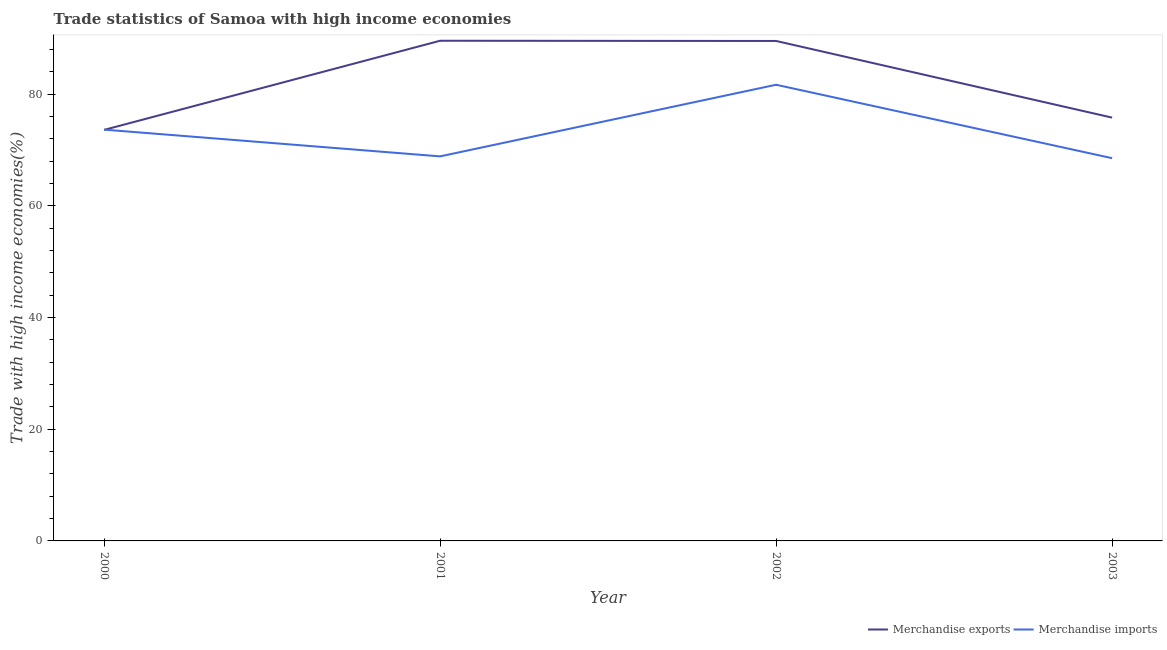How many different coloured lines are there?
Offer a very short reply. 2. Does the line corresponding to merchandise imports intersect with the line corresponding to merchandise exports?
Provide a short and direct response. Yes. Is the number of lines equal to the number of legend labels?
Keep it short and to the point. Yes. What is the merchandise exports in 2000?
Your response must be concise. 73.62. Across all years, what is the maximum merchandise imports?
Provide a succinct answer. 81.71. Across all years, what is the minimum merchandise exports?
Make the answer very short. 73.62. In which year was the merchandise exports maximum?
Offer a terse response. 2001. What is the total merchandise imports in the graph?
Ensure brevity in your answer.  292.82. What is the difference between the merchandise imports in 2000 and that in 2001?
Make the answer very short. 4.79. What is the difference between the merchandise exports in 2002 and the merchandise imports in 2001?
Your response must be concise. 20.67. What is the average merchandise imports per year?
Make the answer very short. 73.21. In the year 2002, what is the difference between the merchandise exports and merchandise imports?
Your answer should be very brief. 7.84. In how many years, is the merchandise imports greater than 12 %?
Offer a very short reply. 4. What is the ratio of the merchandise exports in 2002 to that in 2003?
Make the answer very short. 1.18. Is the merchandise imports in 2001 less than that in 2003?
Provide a succinct answer. No. Is the difference between the merchandise exports in 2000 and 2001 greater than the difference between the merchandise imports in 2000 and 2001?
Give a very brief answer. No. What is the difference between the highest and the second highest merchandise exports?
Make the answer very short. 0.04. What is the difference between the highest and the lowest merchandise exports?
Offer a very short reply. 15.97. Is the merchandise imports strictly less than the merchandise exports over the years?
Ensure brevity in your answer.  No. Are the values on the major ticks of Y-axis written in scientific E-notation?
Your answer should be very brief. No. What is the title of the graph?
Make the answer very short. Trade statistics of Samoa with high income economies. Does "Non-resident workers" appear as one of the legend labels in the graph?
Provide a short and direct response. No. What is the label or title of the Y-axis?
Give a very brief answer. Trade with high income economies(%). What is the Trade with high income economies(%) of Merchandise exports in 2000?
Your answer should be compact. 73.62. What is the Trade with high income economies(%) of Merchandise imports in 2000?
Offer a very short reply. 73.67. What is the Trade with high income economies(%) of Merchandise exports in 2001?
Keep it short and to the point. 89.59. What is the Trade with high income economies(%) of Merchandise imports in 2001?
Provide a short and direct response. 68.88. What is the Trade with high income economies(%) in Merchandise exports in 2002?
Your answer should be very brief. 89.55. What is the Trade with high income economies(%) of Merchandise imports in 2002?
Your answer should be compact. 81.71. What is the Trade with high income economies(%) of Merchandise exports in 2003?
Your answer should be very brief. 75.82. What is the Trade with high income economies(%) in Merchandise imports in 2003?
Make the answer very short. 68.56. Across all years, what is the maximum Trade with high income economies(%) of Merchandise exports?
Offer a terse response. 89.59. Across all years, what is the maximum Trade with high income economies(%) in Merchandise imports?
Ensure brevity in your answer.  81.71. Across all years, what is the minimum Trade with high income economies(%) in Merchandise exports?
Make the answer very short. 73.62. Across all years, what is the minimum Trade with high income economies(%) in Merchandise imports?
Ensure brevity in your answer.  68.56. What is the total Trade with high income economies(%) of Merchandise exports in the graph?
Give a very brief answer. 328.59. What is the total Trade with high income economies(%) of Merchandise imports in the graph?
Keep it short and to the point. 292.82. What is the difference between the Trade with high income economies(%) of Merchandise exports in 2000 and that in 2001?
Provide a succinct answer. -15.97. What is the difference between the Trade with high income economies(%) of Merchandise imports in 2000 and that in 2001?
Your answer should be very brief. 4.79. What is the difference between the Trade with high income economies(%) in Merchandise exports in 2000 and that in 2002?
Keep it short and to the point. -15.93. What is the difference between the Trade with high income economies(%) of Merchandise imports in 2000 and that in 2002?
Keep it short and to the point. -8.04. What is the difference between the Trade with high income economies(%) in Merchandise exports in 2000 and that in 2003?
Keep it short and to the point. -2.2. What is the difference between the Trade with high income economies(%) in Merchandise imports in 2000 and that in 2003?
Your answer should be compact. 5.11. What is the difference between the Trade with high income economies(%) in Merchandise exports in 2001 and that in 2002?
Provide a short and direct response. 0.04. What is the difference between the Trade with high income economies(%) of Merchandise imports in 2001 and that in 2002?
Your answer should be compact. -12.83. What is the difference between the Trade with high income economies(%) of Merchandise exports in 2001 and that in 2003?
Your answer should be very brief. 13.77. What is the difference between the Trade with high income economies(%) of Merchandise imports in 2001 and that in 2003?
Ensure brevity in your answer.  0.32. What is the difference between the Trade with high income economies(%) of Merchandise exports in 2002 and that in 2003?
Give a very brief answer. 13.73. What is the difference between the Trade with high income economies(%) of Merchandise imports in 2002 and that in 2003?
Offer a terse response. 13.15. What is the difference between the Trade with high income economies(%) in Merchandise exports in 2000 and the Trade with high income economies(%) in Merchandise imports in 2001?
Your answer should be very brief. 4.74. What is the difference between the Trade with high income economies(%) of Merchandise exports in 2000 and the Trade with high income economies(%) of Merchandise imports in 2002?
Provide a succinct answer. -8.09. What is the difference between the Trade with high income economies(%) in Merchandise exports in 2000 and the Trade with high income economies(%) in Merchandise imports in 2003?
Provide a short and direct response. 5.07. What is the difference between the Trade with high income economies(%) in Merchandise exports in 2001 and the Trade with high income economies(%) in Merchandise imports in 2002?
Make the answer very short. 7.88. What is the difference between the Trade with high income economies(%) of Merchandise exports in 2001 and the Trade with high income economies(%) of Merchandise imports in 2003?
Provide a short and direct response. 21.03. What is the difference between the Trade with high income economies(%) in Merchandise exports in 2002 and the Trade with high income economies(%) in Merchandise imports in 2003?
Offer a terse response. 20.99. What is the average Trade with high income economies(%) in Merchandise exports per year?
Your response must be concise. 82.15. What is the average Trade with high income economies(%) of Merchandise imports per year?
Keep it short and to the point. 73.21. In the year 2000, what is the difference between the Trade with high income economies(%) in Merchandise exports and Trade with high income economies(%) in Merchandise imports?
Your response must be concise. -0.05. In the year 2001, what is the difference between the Trade with high income economies(%) of Merchandise exports and Trade with high income economies(%) of Merchandise imports?
Your answer should be compact. 20.71. In the year 2002, what is the difference between the Trade with high income economies(%) of Merchandise exports and Trade with high income economies(%) of Merchandise imports?
Keep it short and to the point. 7.84. In the year 2003, what is the difference between the Trade with high income economies(%) in Merchandise exports and Trade with high income economies(%) in Merchandise imports?
Make the answer very short. 7.26. What is the ratio of the Trade with high income economies(%) of Merchandise exports in 2000 to that in 2001?
Ensure brevity in your answer.  0.82. What is the ratio of the Trade with high income economies(%) in Merchandise imports in 2000 to that in 2001?
Your answer should be very brief. 1.07. What is the ratio of the Trade with high income economies(%) in Merchandise exports in 2000 to that in 2002?
Your response must be concise. 0.82. What is the ratio of the Trade with high income economies(%) of Merchandise imports in 2000 to that in 2002?
Provide a succinct answer. 0.9. What is the ratio of the Trade with high income economies(%) in Merchandise imports in 2000 to that in 2003?
Offer a very short reply. 1.07. What is the ratio of the Trade with high income economies(%) in Merchandise imports in 2001 to that in 2002?
Keep it short and to the point. 0.84. What is the ratio of the Trade with high income economies(%) of Merchandise exports in 2001 to that in 2003?
Give a very brief answer. 1.18. What is the ratio of the Trade with high income economies(%) of Merchandise exports in 2002 to that in 2003?
Your answer should be very brief. 1.18. What is the ratio of the Trade with high income economies(%) in Merchandise imports in 2002 to that in 2003?
Offer a terse response. 1.19. What is the difference between the highest and the second highest Trade with high income economies(%) of Merchandise exports?
Keep it short and to the point. 0.04. What is the difference between the highest and the second highest Trade with high income economies(%) in Merchandise imports?
Provide a short and direct response. 8.04. What is the difference between the highest and the lowest Trade with high income economies(%) in Merchandise exports?
Provide a short and direct response. 15.97. What is the difference between the highest and the lowest Trade with high income economies(%) of Merchandise imports?
Your answer should be very brief. 13.15. 